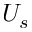<formula> <loc_0><loc_0><loc_500><loc_500>U _ { s }</formula> 